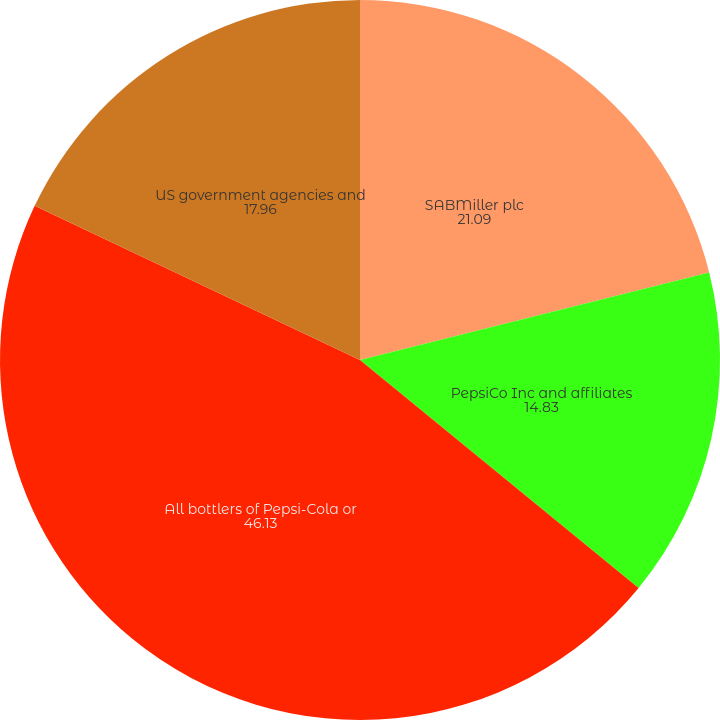Convert chart to OTSL. <chart><loc_0><loc_0><loc_500><loc_500><pie_chart><fcel>SABMiller plc<fcel>PepsiCo Inc and affiliates<fcel>All bottlers of Pepsi-Cola or<fcel>US government agencies and<nl><fcel>21.09%<fcel>14.83%<fcel>46.13%<fcel>17.96%<nl></chart> 